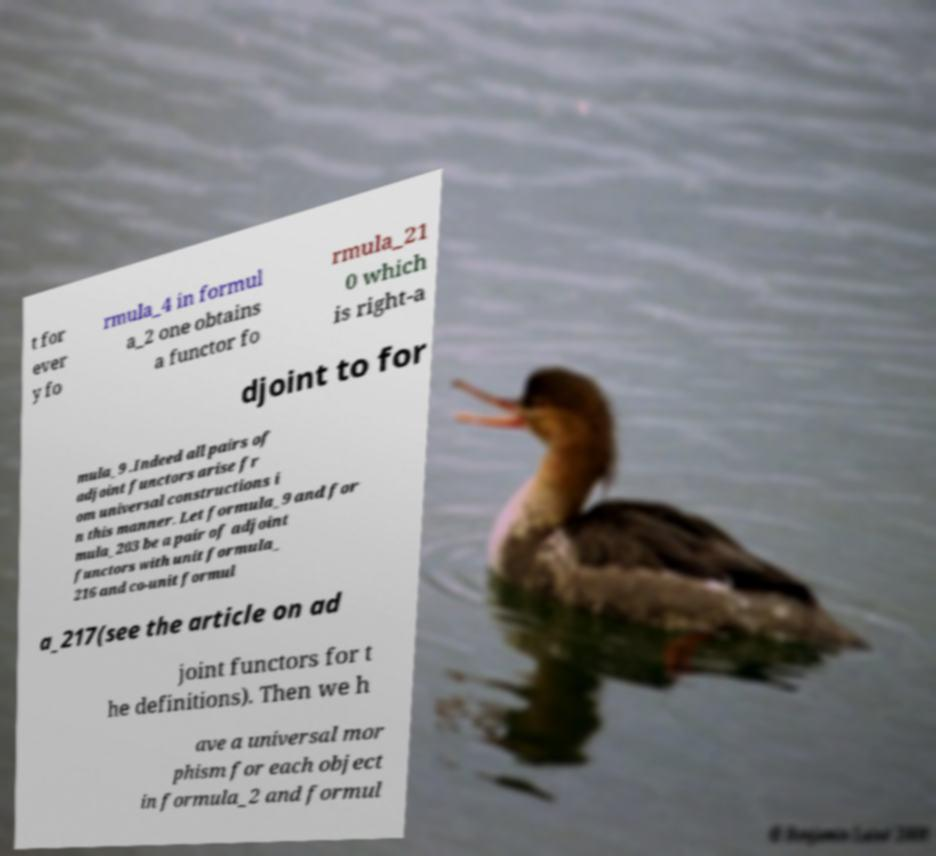There's text embedded in this image that I need extracted. Can you transcribe it verbatim? t for ever y fo rmula_4 in formul a_2 one obtains a functor fo rmula_21 0 which is right-a djoint to for mula_9 .Indeed all pairs of adjoint functors arise fr om universal constructions i n this manner. Let formula_9 and for mula_203 be a pair of adjoint functors with unit formula_ 216 and co-unit formul a_217(see the article on ad joint functors for t he definitions). Then we h ave a universal mor phism for each object in formula_2 and formul 